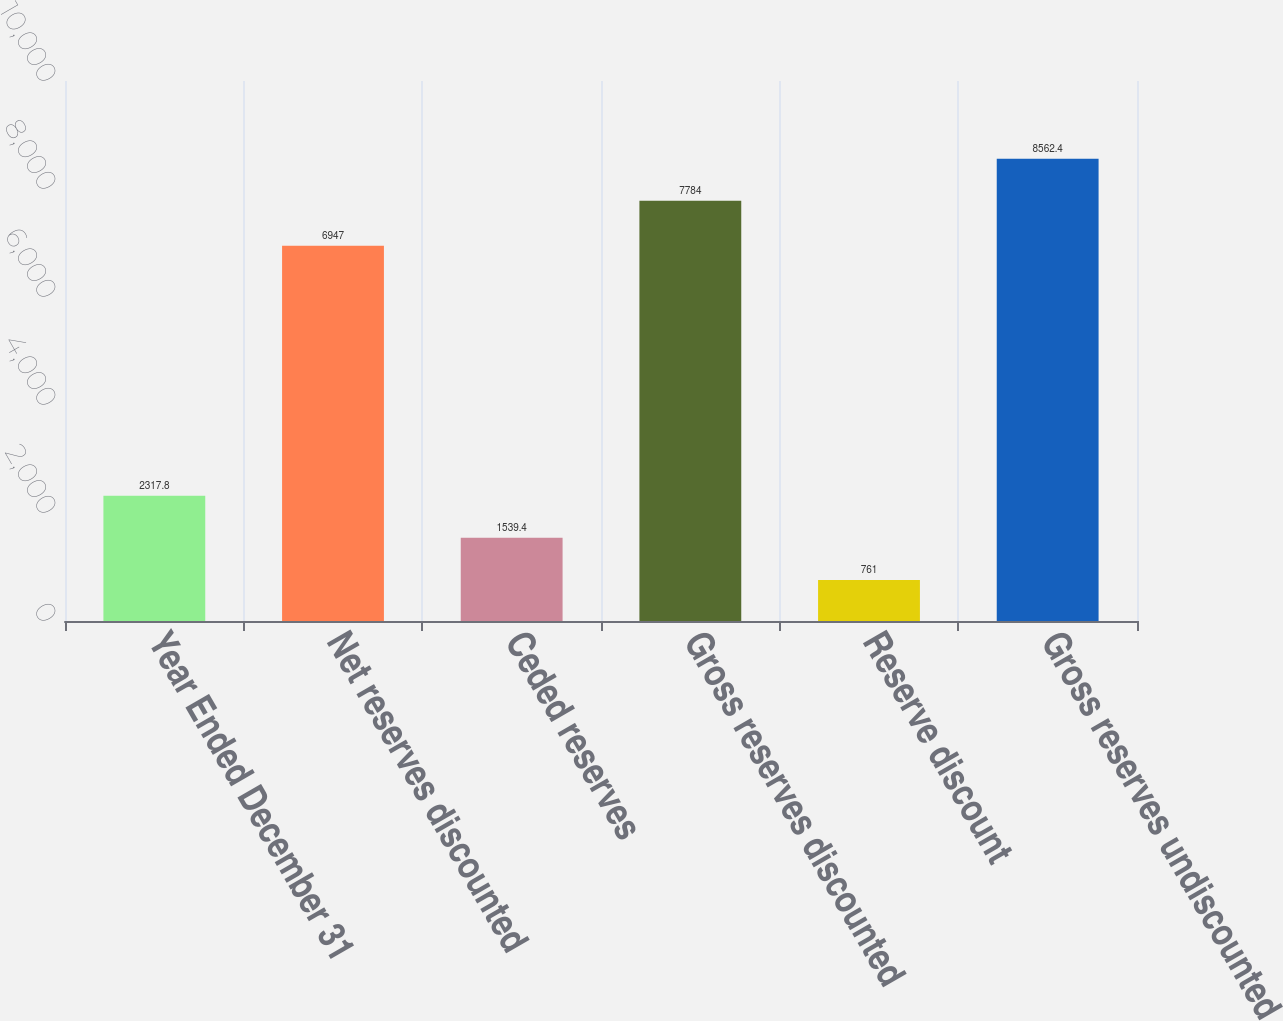Convert chart to OTSL. <chart><loc_0><loc_0><loc_500><loc_500><bar_chart><fcel>Year Ended December 31<fcel>Net reserves discounted<fcel>Ceded reserves<fcel>Gross reserves discounted<fcel>Reserve discount<fcel>Gross reserves undiscounted<nl><fcel>2317.8<fcel>6947<fcel>1539.4<fcel>7784<fcel>761<fcel>8562.4<nl></chart> 